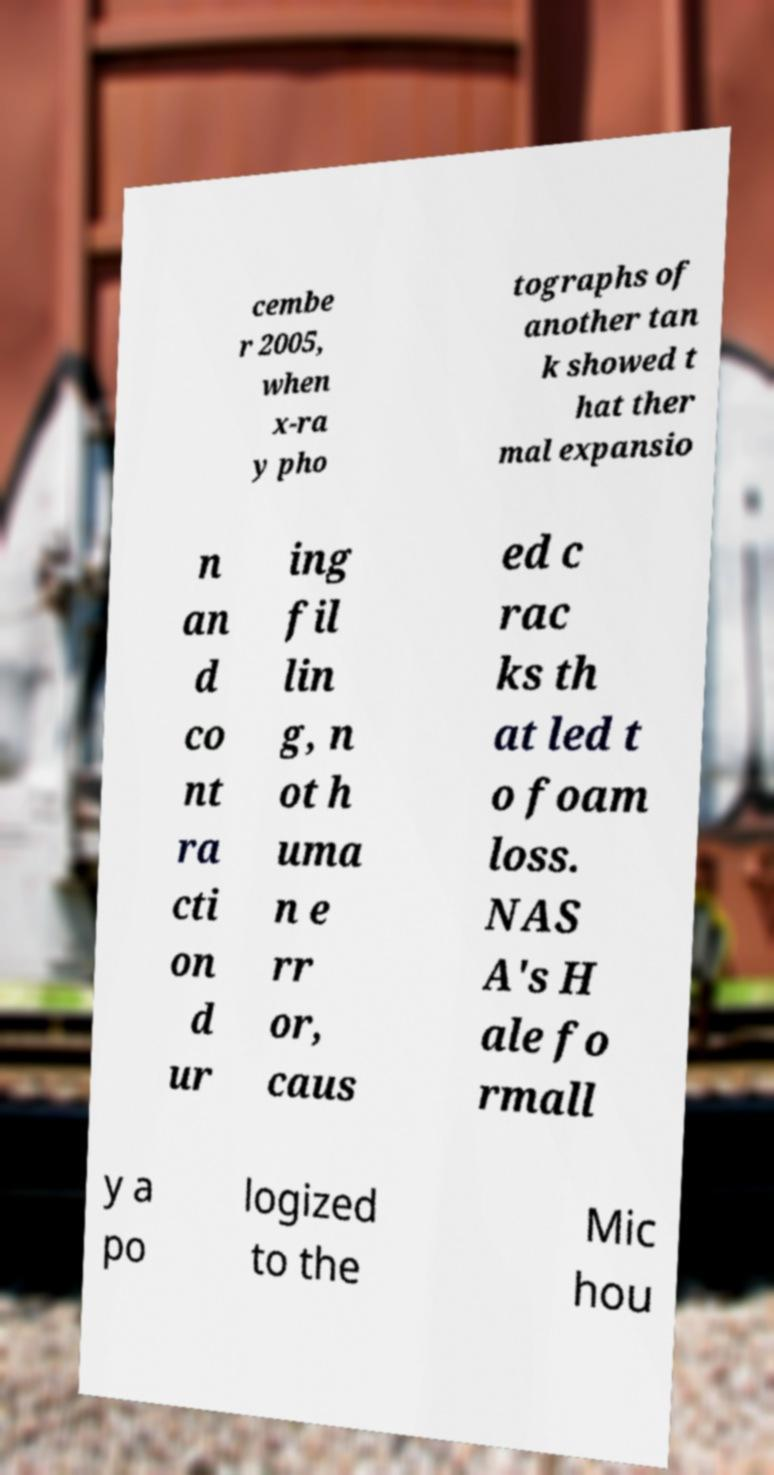I need the written content from this picture converted into text. Can you do that? cembe r 2005, when x-ra y pho tographs of another tan k showed t hat ther mal expansio n an d co nt ra cti on d ur ing fil lin g, n ot h uma n e rr or, caus ed c rac ks th at led t o foam loss. NAS A's H ale fo rmall y a po logized to the Mic hou 